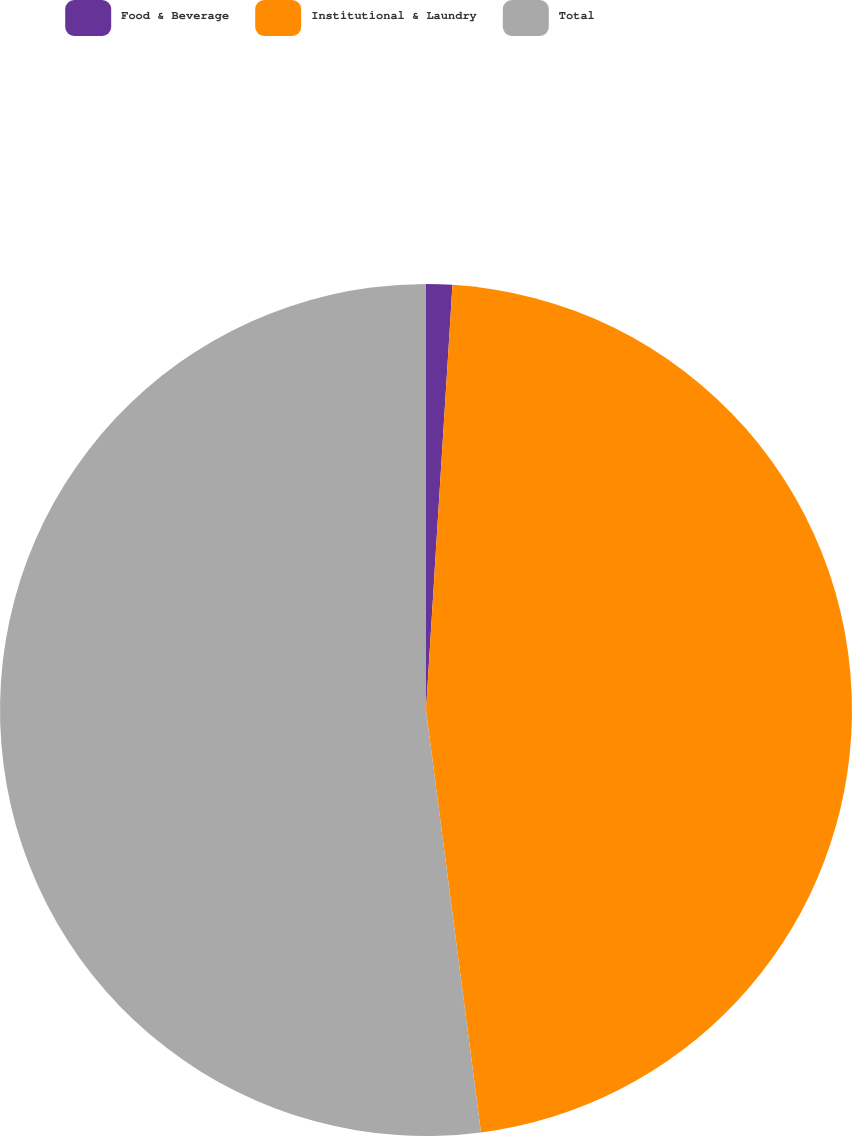Convert chart to OTSL. <chart><loc_0><loc_0><loc_500><loc_500><pie_chart><fcel>Food & Beverage<fcel>Institutional & Laundry<fcel>Total<nl><fcel>0.99%<fcel>46.95%<fcel>52.06%<nl></chart> 